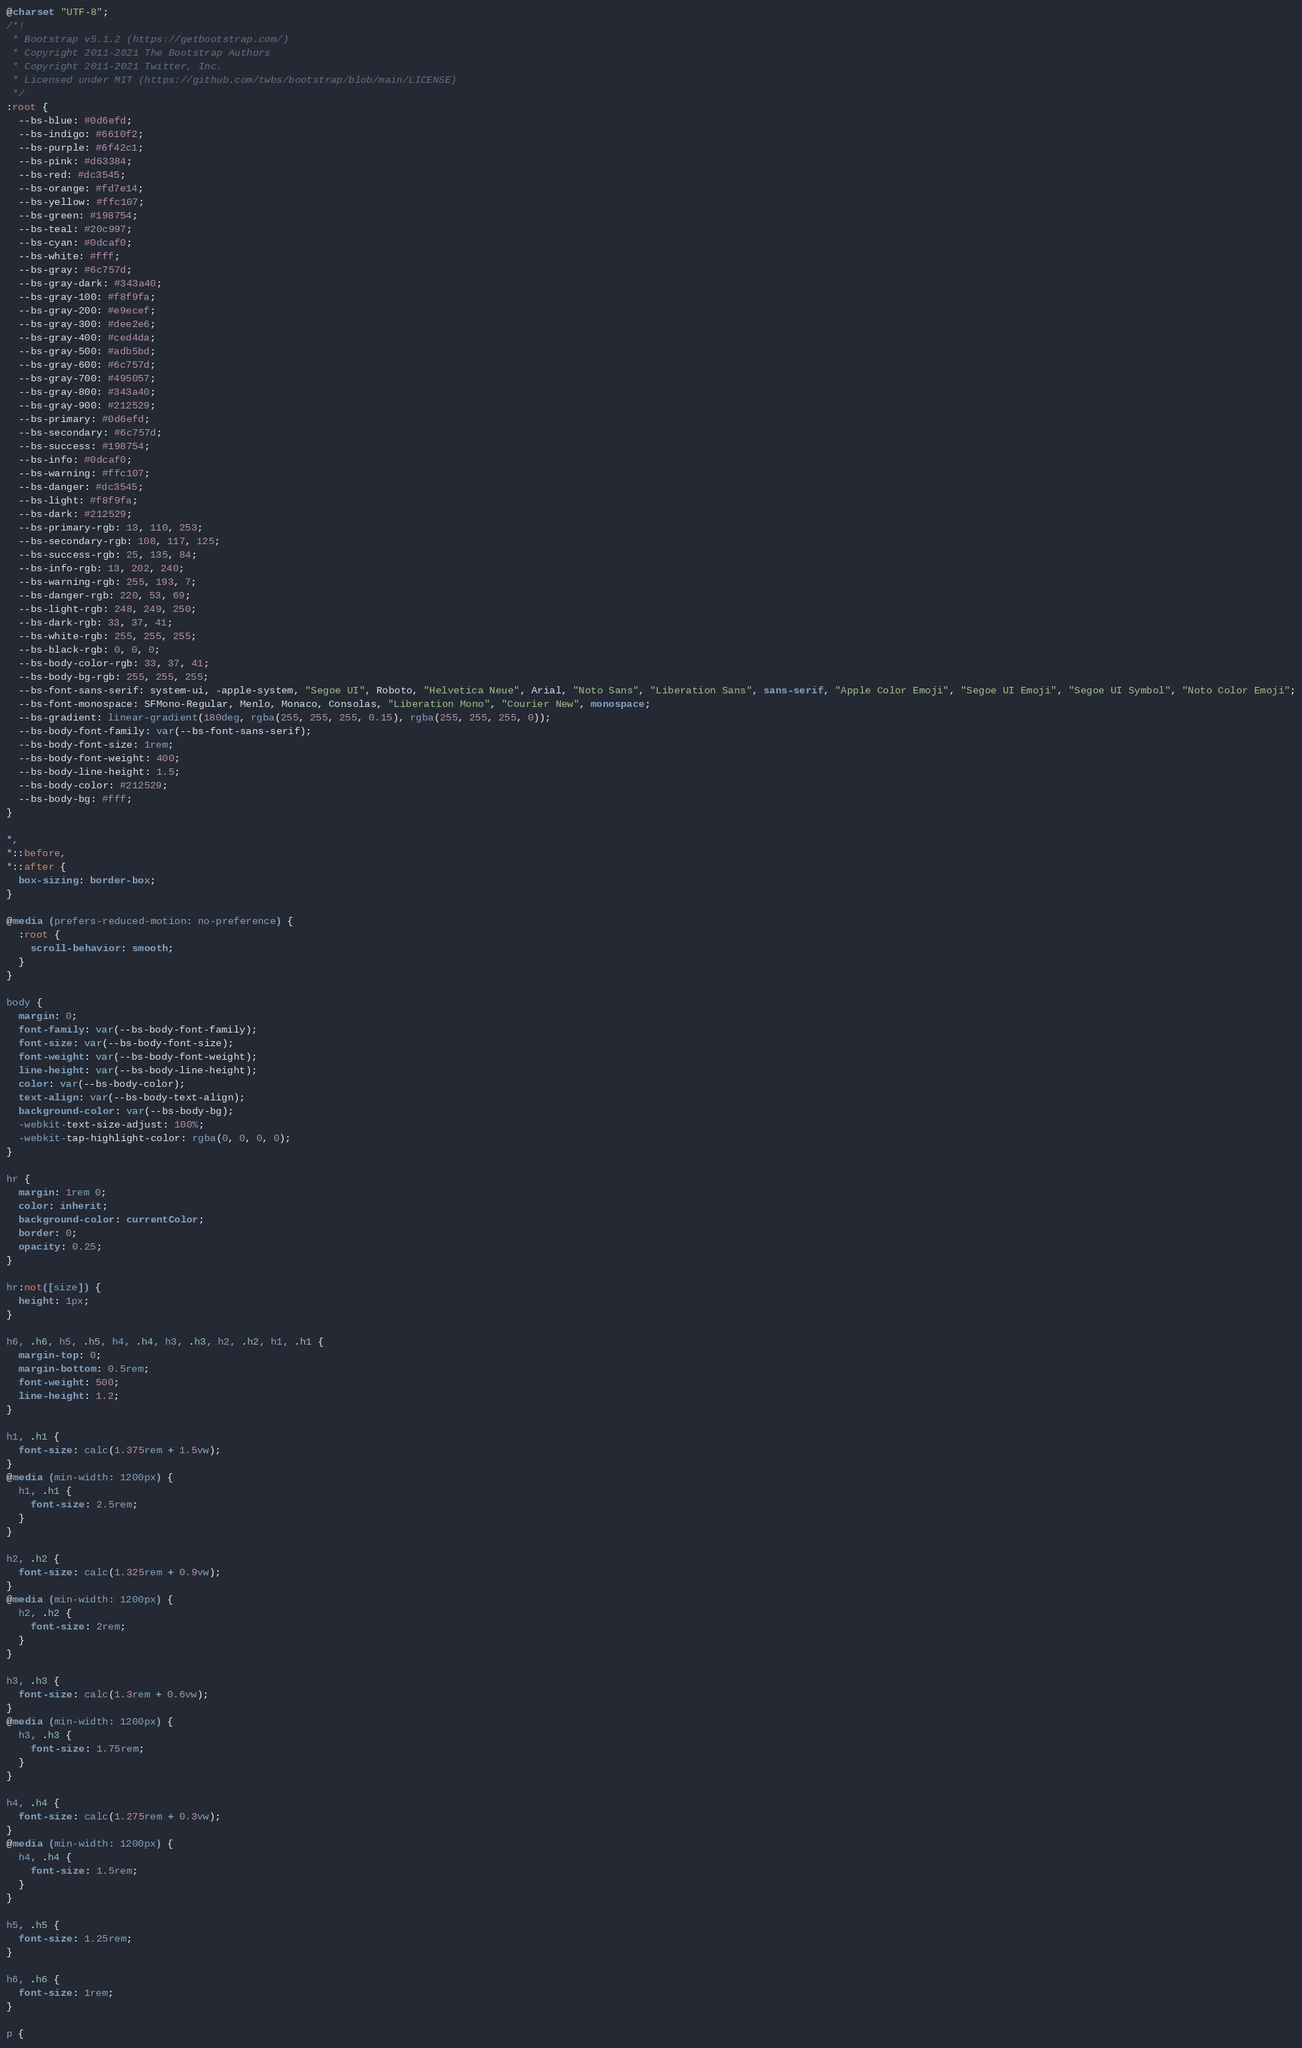Convert code to text. <code><loc_0><loc_0><loc_500><loc_500><_CSS_>@charset "UTF-8";
/*!
 * Bootstrap v5.1.2 (https://getbootstrap.com/)
 * Copyright 2011-2021 The Bootstrap Authors
 * Copyright 2011-2021 Twitter, Inc.
 * Licensed under MIT (https://github.com/twbs/bootstrap/blob/main/LICENSE)
 */
:root {
  --bs-blue: #0d6efd;
  --bs-indigo: #6610f2;
  --bs-purple: #6f42c1;
  --bs-pink: #d63384;
  --bs-red: #dc3545;
  --bs-orange: #fd7e14;
  --bs-yellow: #ffc107;
  --bs-green: #198754;
  --bs-teal: #20c997;
  --bs-cyan: #0dcaf0;
  --bs-white: #fff;
  --bs-gray: #6c757d;
  --bs-gray-dark: #343a40;
  --bs-gray-100: #f8f9fa;
  --bs-gray-200: #e9ecef;
  --bs-gray-300: #dee2e6;
  --bs-gray-400: #ced4da;
  --bs-gray-500: #adb5bd;
  --bs-gray-600: #6c757d;
  --bs-gray-700: #495057;
  --bs-gray-800: #343a40;
  --bs-gray-900: #212529;
  --bs-primary: #0d6efd;
  --bs-secondary: #6c757d;
  --bs-success: #198754;
  --bs-info: #0dcaf0;
  --bs-warning: #ffc107;
  --bs-danger: #dc3545;
  --bs-light: #f8f9fa;
  --bs-dark: #212529;
  --bs-primary-rgb: 13, 110, 253;
  --bs-secondary-rgb: 108, 117, 125;
  --bs-success-rgb: 25, 135, 84;
  --bs-info-rgb: 13, 202, 240;
  --bs-warning-rgb: 255, 193, 7;
  --bs-danger-rgb: 220, 53, 69;
  --bs-light-rgb: 248, 249, 250;
  --bs-dark-rgb: 33, 37, 41;
  --bs-white-rgb: 255, 255, 255;
  --bs-black-rgb: 0, 0, 0;
  --bs-body-color-rgb: 33, 37, 41;
  --bs-body-bg-rgb: 255, 255, 255;
  --bs-font-sans-serif: system-ui, -apple-system, "Segoe UI", Roboto, "Helvetica Neue", Arial, "Noto Sans", "Liberation Sans", sans-serif, "Apple Color Emoji", "Segoe UI Emoji", "Segoe UI Symbol", "Noto Color Emoji";
  --bs-font-monospace: SFMono-Regular, Menlo, Monaco, Consolas, "Liberation Mono", "Courier New", monospace;
  --bs-gradient: linear-gradient(180deg, rgba(255, 255, 255, 0.15), rgba(255, 255, 255, 0));
  --bs-body-font-family: var(--bs-font-sans-serif);
  --bs-body-font-size: 1rem;
  --bs-body-font-weight: 400;
  --bs-body-line-height: 1.5;
  --bs-body-color: #212529;
  --bs-body-bg: #fff;
}

*,
*::before,
*::after {
  box-sizing: border-box;
}

@media (prefers-reduced-motion: no-preference) {
  :root {
    scroll-behavior: smooth;
  }
}

body {
  margin: 0;
  font-family: var(--bs-body-font-family);
  font-size: var(--bs-body-font-size);
  font-weight: var(--bs-body-font-weight);
  line-height: var(--bs-body-line-height);
  color: var(--bs-body-color);
  text-align: var(--bs-body-text-align);
  background-color: var(--bs-body-bg);
  -webkit-text-size-adjust: 100%;
  -webkit-tap-highlight-color: rgba(0, 0, 0, 0);
}

hr {
  margin: 1rem 0;
  color: inherit;
  background-color: currentColor;
  border: 0;
  opacity: 0.25;
}

hr:not([size]) {
  height: 1px;
}

h6, .h6, h5, .h5, h4, .h4, h3, .h3, h2, .h2, h1, .h1 {
  margin-top: 0;
  margin-bottom: 0.5rem;
  font-weight: 500;
  line-height: 1.2;
}

h1, .h1 {
  font-size: calc(1.375rem + 1.5vw);
}
@media (min-width: 1200px) {
  h1, .h1 {
    font-size: 2.5rem;
  }
}

h2, .h2 {
  font-size: calc(1.325rem + 0.9vw);
}
@media (min-width: 1200px) {
  h2, .h2 {
    font-size: 2rem;
  }
}

h3, .h3 {
  font-size: calc(1.3rem + 0.6vw);
}
@media (min-width: 1200px) {
  h3, .h3 {
    font-size: 1.75rem;
  }
}

h4, .h4 {
  font-size: calc(1.275rem + 0.3vw);
}
@media (min-width: 1200px) {
  h4, .h4 {
    font-size: 1.5rem;
  }
}

h5, .h5 {
  font-size: 1.25rem;
}

h6, .h6 {
  font-size: 1rem;
}

p {</code> 